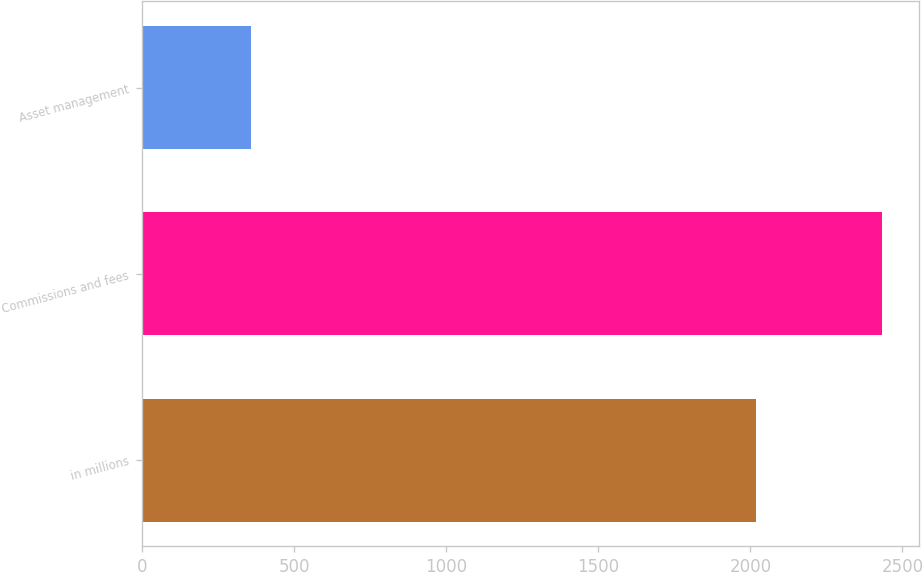Convert chart to OTSL. <chart><loc_0><loc_0><loc_500><loc_500><bar_chart><fcel>in millions<fcel>Commissions and fees<fcel>Asset management<nl><fcel>2017<fcel>2433<fcel>359<nl></chart> 